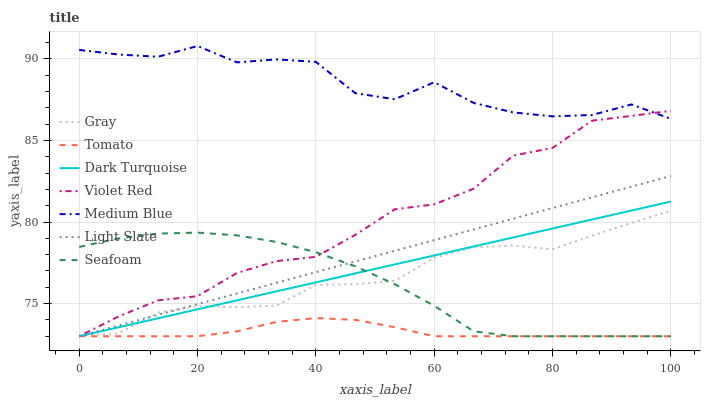Does Tomato have the minimum area under the curve?
Answer yes or no. Yes. Does Medium Blue have the maximum area under the curve?
Answer yes or no. Yes. Does Gray have the minimum area under the curve?
Answer yes or no. No. Does Gray have the maximum area under the curve?
Answer yes or no. No. Is Dark Turquoise the smoothest?
Answer yes or no. Yes. Is Medium Blue the roughest?
Answer yes or no. Yes. Is Gray the smoothest?
Answer yes or no. No. Is Gray the roughest?
Answer yes or no. No. Does Tomato have the lowest value?
Answer yes or no. Yes. Does Gray have the lowest value?
Answer yes or no. No. Does Medium Blue have the highest value?
Answer yes or no. Yes. Does Gray have the highest value?
Answer yes or no. No. Is Seafoam less than Medium Blue?
Answer yes or no. Yes. Is Medium Blue greater than Tomato?
Answer yes or no. Yes. Does Dark Turquoise intersect Seafoam?
Answer yes or no. Yes. Is Dark Turquoise less than Seafoam?
Answer yes or no. No. Is Dark Turquoise greater than Seafoam?
Answer yes or no. No. Does Seafoam intersect Medium Blue?
Answer yes or no. No. 